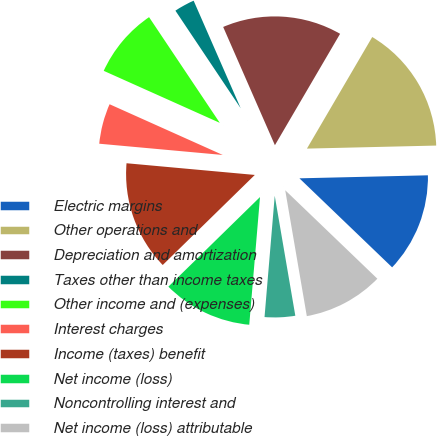Convert chart. <chart><loc_0><loc_0><loc_500><loc_500><pie_chart><fcel>Electric margins<fcel>Other operations and<fcel>Depreciation and amortization<fcel>Taxes other than income taxes<fcel>Other income and (expenses)<fcel>Interest charges<fcel>Income (taxes) benefit<fcel>Net income (loss)<fcel>Noncontrolling interest and<fcel>Net income (loss) attributable<nl><fcel>12.55%<fcel>16.2%<fcel>14.99%<fcel>2.82%<fcel>8.91%<fcel>5.26%<fcel>13.77%<fcel>11.34%<fcel>4.04%<fcel>10.12%<nl></chart> 